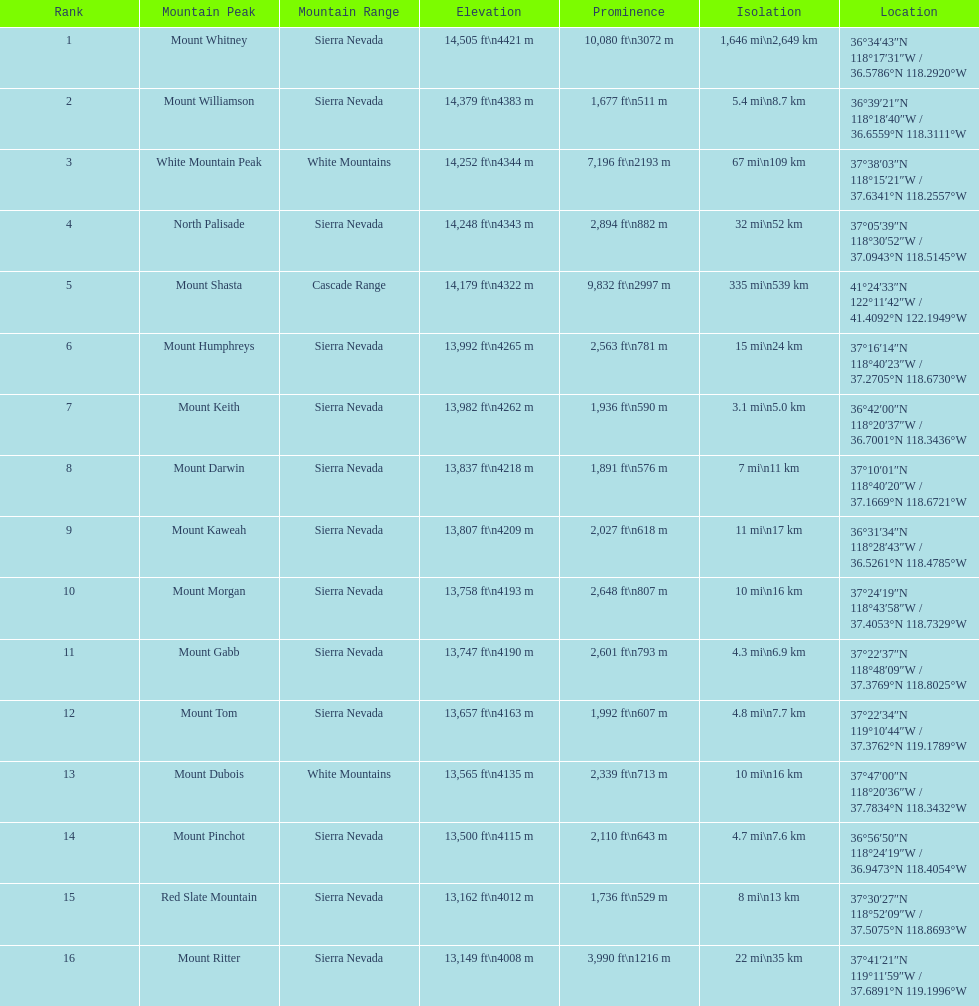Which has greater elevation, mount humphreys or mount kaweah? Mount Humphreys. 